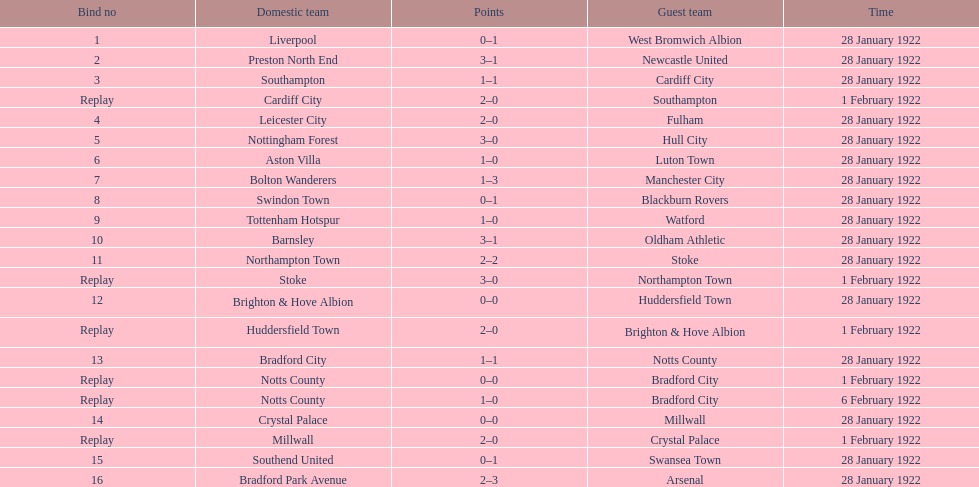In how many games were four or more total points scored? 5. 